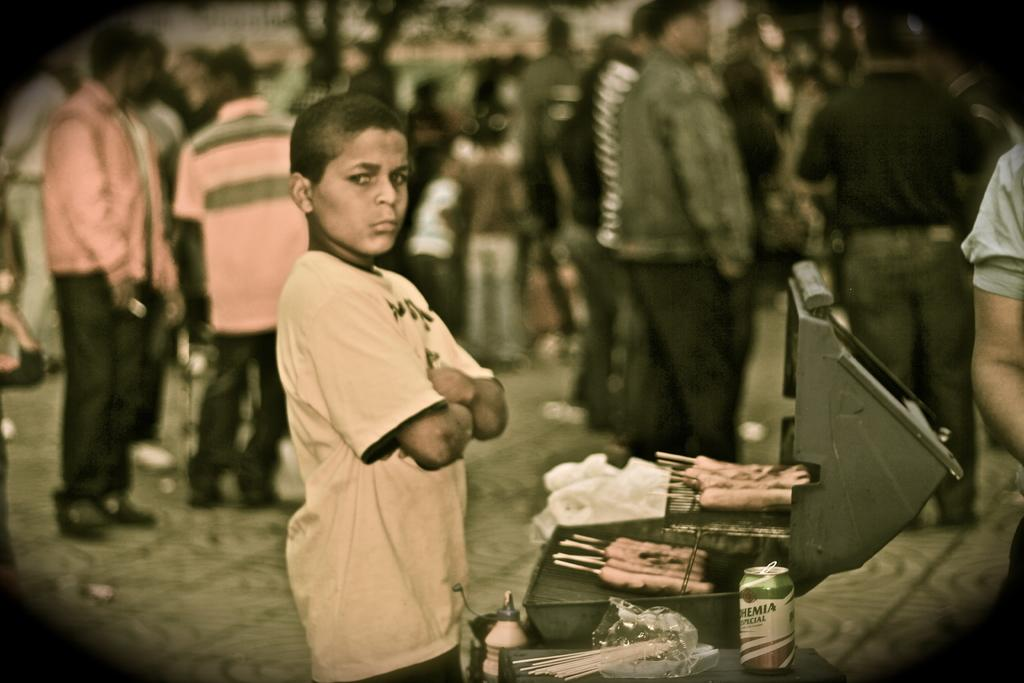What is the main subject of the image? The main subject of the image is a boy standing. What is the boy wearing in the image? The boy is wearing a t-shirt in the image. What activity is being performed in the image? Food is being grilled in the image. Can you describe the people in the background of the image? There are people standing in the background of the image. How many buns are placed on the grill in the image? There is no mention of buns in the image; it only shows food being grilled. What type of vest is the boy wearing in the image? The boy is not wearing a vest in the image; he is wearing a t-shirt. 